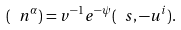Convert formula to latex. <formula><loc_0><loc_0><loc_500><loc_500>( \ n ^ { \alpha } ) = v ^ { - 1 } e ^ { - \psi } ( \ s , - u ^ { i } ) .</formula> 